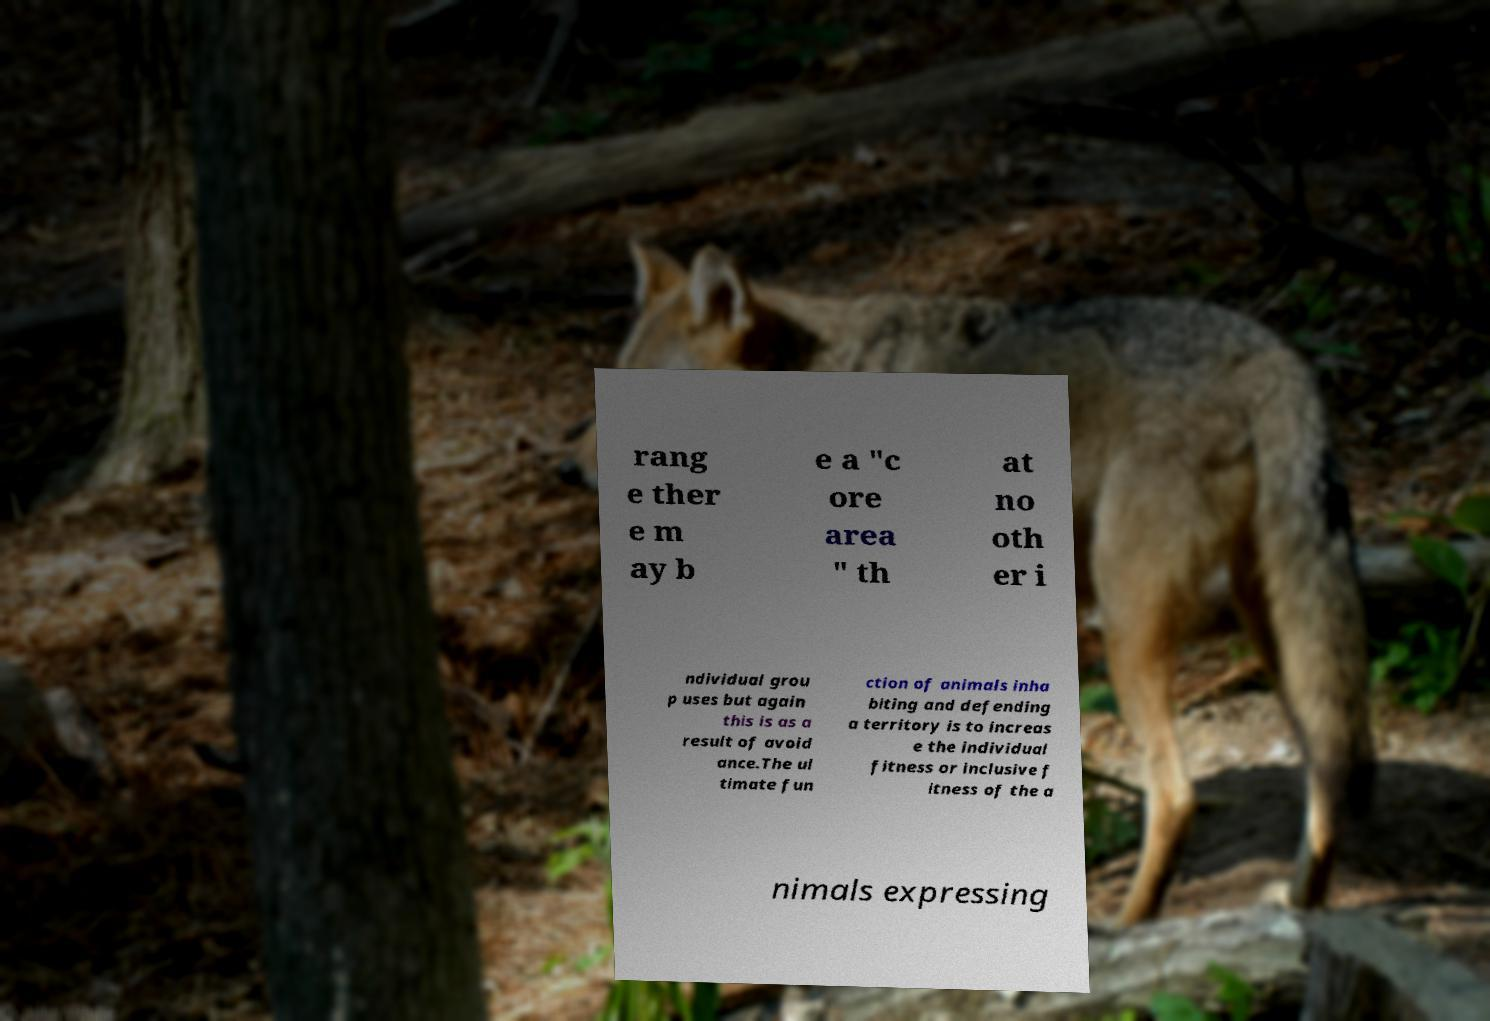Can you accurately transcribe the text from the provided image for me? rang e ther e m ay b e a "c ore area " th at no oth er i ndividual grou p uses but again this is as a result of avoid ance.The ul timate fun ction of animals inha biting and defending a territory is to increas e the individual fitness or inclusive f itness of the a nimals expressing 